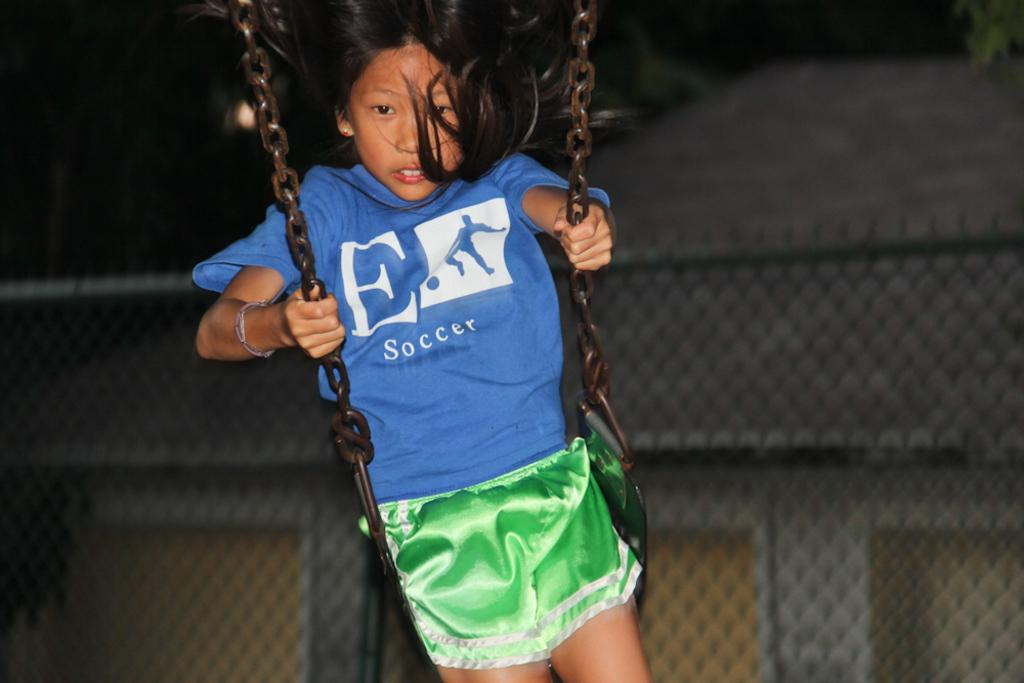Provide a one-sentence caption for the provided image. Girl wearing  shirt that says "Soccer" swinging on the swings. 